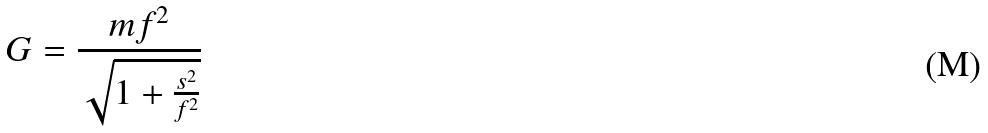<formula> <loc_0><loc_0><loc_500><loc_500>G = \frac { m f ^ { 2 } } { \sqrt { 1 + \frac { s ^ { 2 } } { f ^ { 2 } } } }</formula> 